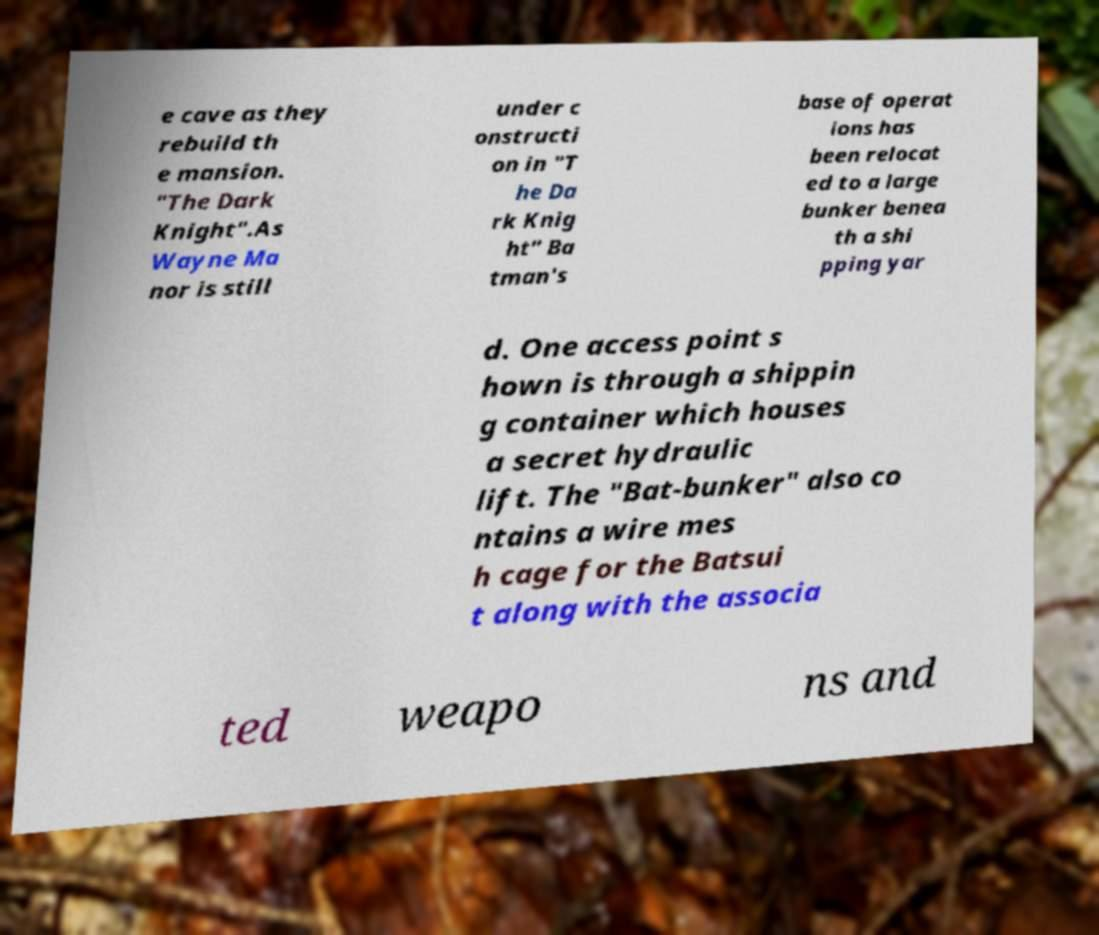Please identify and transcribe the text found in this image. e cave as they rebuild th e mansion. "The Dark Knight".As Wayne Ma nor is still under c onstructi on in "T he Da rk Knig ht" Ba tman's base of operat ions has been relocat ed to a large bunker benea th a shi pping yar d. One access point s hown is through a shippin g container which houses a secret hydraulic lift. The "Bat-bunker" also co ntains a wire mes h cage for the Batsui t along with the associa ted weapo ns and 